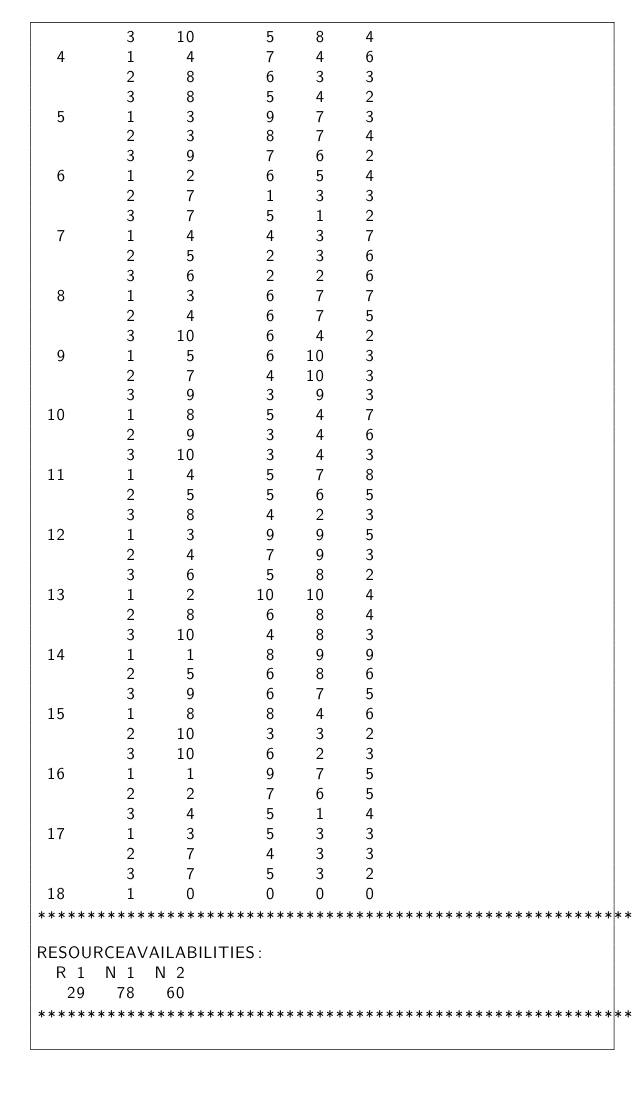Convert code to text. <code><loc_0><loc_0><loc_500><loc_500><_ObjectiveC_>         3    10       5    8    4
  4      1     4       7    4    6
         2     8       6    3    3
         3     8       5    4    2
  5      1     3       9    7    3
         2     3       8    7    4
         3     9       7    6    2
  6      1     2       6    5    4
         2     7       1    3    3
         3     7       5    1    2
  7      1     4       4    3    7
         2     5       2    3    6
         3     6       2    2    6
  8      1     3       6    7    7
         2     4       6    7    5
         3    10       6    4    2
  9      1     5       6   10    3
         2     7       4   10    3
         3     9       3    9    3
 10      1     8       5    4    7
         2     9       3    4    6
         3    10       3    4    3
 11      1     4       5    7    8
         2     5       5    6    5
         3     8       4    2    3
 12      1     3       9    9    5
         2     4       7    9    3
         3     6       5    8    2
 13      1     2      10   10    4
         2     8       6    8    4
         3    10       4    8    3
 14      1     1       8    9    9
         2     5       6    8    6
         3     9       6    7    5
 15      1     8       8    4    6
         2    10       3    3    2
         3    10       6    2    3
 16      1     1       9    7    5
         2     2       7    6    5
         3     4       5    1    4
 17      1     3       5    3    3
         2     7       4    3    3
         3     7       5    3    2
 18      1     0       0    0    0
************************************************************************
RESOURCEAVAILABILITIES:
  R 1  N 1  N 2
   29   78   60
************************************************************************
</code> 